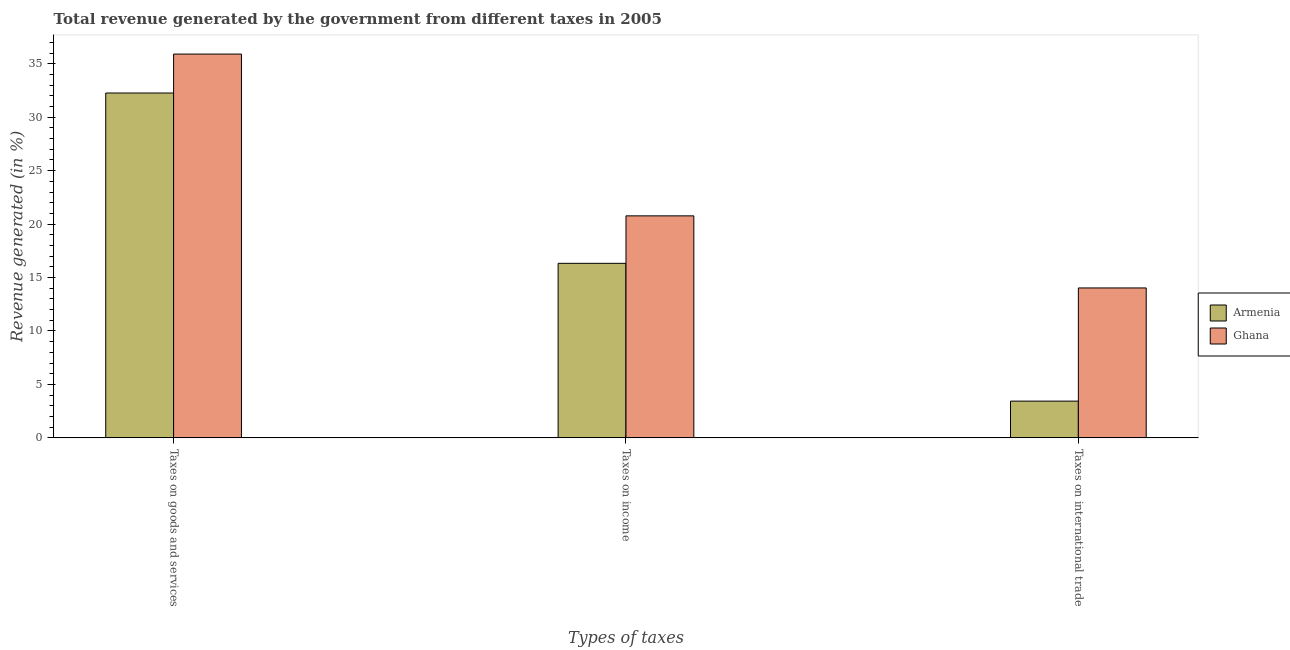How many different coloured bars are there?
Your response must be concise. 2. How many groups of bars are there?
Your answer should be very brief. 3. Are the number of bars on each tick of the X-axis equal?
Ensure brevity in your answer.  Yes. What is the label of the 1st group of bars from the left?
Ensure brevity in your answer.  Taxes on goods and services. What is the percentage of revenue generated by taxes on income in Ghana?
Keep it short and to the point. 20.77. Across all countries, what is the maximum percentage of revenue generated by tax on international trade?
Make the answer very short. 14.02. Across all countries, what is the minimum percentage of revenue generated by taxes on income?
Give a very brief answer. 16.33. In which country was the percentage of revenue generated by taxes on goods and services minimum?
Give a very brief answer. Armenia. What is the total percentage of revenue generated by taxes on income in the graph?
Offer a very short reply. 37.1. What is the difference between the percentage of revenue generated by tax on international trade in Ghana and that in Armenia?
Provide a short and direct response. 10.59. What is the difference between the percentage of revenue generated by tax on international trade in Armenia and the percentage of revenue generated by taxes on goods and services in Ghana?
Your answer should be very brief. -32.46. What is the average percentage of revenue generated by taxes on goods and services per country?
Give a very brief answer. 34.08. What is the difference between the percentage of revenue generated by taxes on income and percentage of revenue generated by taxes on goods and services in Armenia?
Your response must be concise. -15.93. In how many countries, is the percentage of revenue generated by taxes on income greater than 23 %?
Your response must be concise. 0. What is the ratio of the percentage of revenue generated by tax on international trade in Ghana to that in Armenia?
Provide a succinct answer. 4.08. Is the difference between the percentage of revenue generated by taxes on income in Armenia and Ghana greater than the difference between the percentage of revenue generated by tax on international trade in Armenia and Ghana?
Your answer should be very brief. Yes. What is the difference between the highest and the second highest percentage of revenue generated by tax on international trade?
Keep it short and to the point. 10.59. What is the difference between the highest and the lowest percentage of revenue generated by taxes on income?
Offer a terse response. 4.44. In how many countries, is the percentage of revenue generated by taxes on goods and services greater than the average percentage of revenue generated by taxes on goods and services taken over all countries?
Make the answer very short. 1. What does the 2nd bar from the left in Taxes on goods and services represents?
Make the answer very short. Ghana. How many bars are there?
Ensure brevity in your answer.  6. Are all the bars in the graph horizontal?
Offer a very short reply. No. What is the difference between two consecutive major ticks on the Y-axis?
Ensure brevity in your answer.  5. Are the values on the major ticks of Y-axis written in scientific E-notation?
Offer a very short reply. No. Does the graph contain any zero values?
Provide a succinct answer. No. What is the title of the graph?
Keep it short and to the point. Total revenue generated by the government from different taxes in 2005. What is the label or title of the X-axis?
Your response must be concise. Types of taxes. What is the label or title of the Y-axis?
Keep it short and to the point. Revenue generated (in %). What is the Revenue generated (in %) in Armenia in Taxes on goods and services?
Keep it short and to the point. 32.26. What is the Revenue generated (in %) in Ghana in Taxes on goods and services?
Your answer should be very brief. 35.9. What is the Revenue generated (in %) of Armenia in Taxes on income?
Provide a short and direct response. 16.33. What is the Revenue generated (in %) in Ghana in Taxes on income?
Give a very brief answer. 20.77. What is the Revenue generated (in %) in Armenia in Taxes on international trade?
Provide a short and direct response. 3.44. What is the Revenue generated (in %) in Ghana in Taxes on international trade?
Provide a short and direct response. 14.02. Across all Types of taxes, what is the maximum Revenue generated (in %) in Armenia?
Make the answer very short. 32.26. Across all Types of taxes, what is the maximum Revenue generated (in %) of Ghana?
Offer a very short reply. 35.9. Across all Types of taxes, what is the minimum Revenue generated (in %) in Armenia?
Give a very brief answer. 3.44. Across all Types of taxes, what is the minimum Revenue generated (in %) of Ghana?
Give a very brief answer. 14.02. What is the total Revenue generated (in %) in Armenia in the graph?
Provide a succinct answer. 52.03. What is the total Revenue generated (in %) of Ghana in the graph?
Provide a succinct answer. 70.7. What is the difference between the Revenue generated (in %) of Armenia in Taxes on goods and services and that in Taxes on income?
Make the answer very short. 15.93. What is the difference between the Revenue generated (in %) in Ghana in Taxes on goods and services and that in Taxes on income?
Your response must be concise. 15.14. What is the difference between the Revenue generated (in %) of Armenia in Taxes on goods and services and that in Taxes on international trade?
Your response must be concise. 28.82. What is the difference between the Revenue generated (in %) of Ghana in Taxes on goods and services and that in Taxes on international trade?
Your answer should be very brief. 21.88. What is the difference between the Revenue generated (in %) of Armenia in Taxes on income and that in Taxes on international trade?
Keep it short and to the point. 12.89. What is the difference between the Revenue generated (in %) of Ghana in Taxes on income and that in Taxes on international trade?
Your answer should be compact. 6.74. What is the difference between the Revenue generated (in %) of Armenia in Taxes on goods and services and the Revenue generated (in %) of Ghana in Taxes on income?
Provide a short and direct response. 11.49. What is the difference between the Revenue generated (in %) of Armenia in Taxes on goods and services and the Revenue generated (in %) of Ghana in Taxes on international trade?
Your answer should be compact. 18.24. What is the difference between the Revenue generated (in %) in Armenia in Taxes on income and the Revenue generated (in %) in Ghana in Taxes on international trade?
Offer a terse response. 2.3. What is the average Revenue generated (in %) in Armenia per Types of taxes?
Give a very brief answer. 17.34. What is the average Revenue generated (in %) in Ghana per Types of taxes?
Offer a terse response. 23.57. What is the difference between the Revenue generated (in %) in Armenia and Revenue generated (in %) in Ghana in Taxes on goods and services?
Ensure brevity in your answer.  -3.64. What is the difference between the Revenue generated (in %) of Armenia and Revenue generated (in %) of Ghana in Taxes on income?
Offer a very short reply. -4.44. What is the difference between the Revenue generated (in %) of Armenia and Revenue generated (in %) of Ghana in Taxes on international trade?
Give a very brief answer. -10.59. What is the ratio of the Revenue generated (in %) in Armenia in Taxes on goods and services to that in Taxes on income?
Your answer should be very brief. 1.98. What is the ratio of the Revenue generated (in %) of Ghana in Taxes on goods and services to that in Taxes on income?
Give a very brief answer. 1.73. What is the ratio of the Revenue generated (in %) in Armenia in Taxes on goods and services to that in Taxes on international trade?
Your answer should be very brief. 9.38. What is the ratio of the Revenue generated (in %) in Ghana in Taxes on goods and services to that in Taxes on international trade?
Your answer should be very brief. 2.56. What is the ratio of the Revenue generated (in %) in Armenia in Taxes on income to that in Taxes on international trade?
Provide a succinct answer. 4.75. What is the ratio of the Revenue generated (in %) of Ghana in Taxes on income to that in Taxes on international trade?
Provide a short and direct response. 1.48. What is the difference between the highest and the second highest Revenue generated (in %) in Armenia?
Make the answer very short. 15.93. What is the difference between the highest and the second highest Revenue generated (in %) of Ghana?
Ensure brevity in your answer.  15.14. What is the difference between the highest and the lowest Revenue generated (in %) in Armenia?
Your answer should be compact. 28.82. What is the difference between the highest and the lowest Revenue generated (in %) of Ghana?
Give a very brief answer. 21.88. 